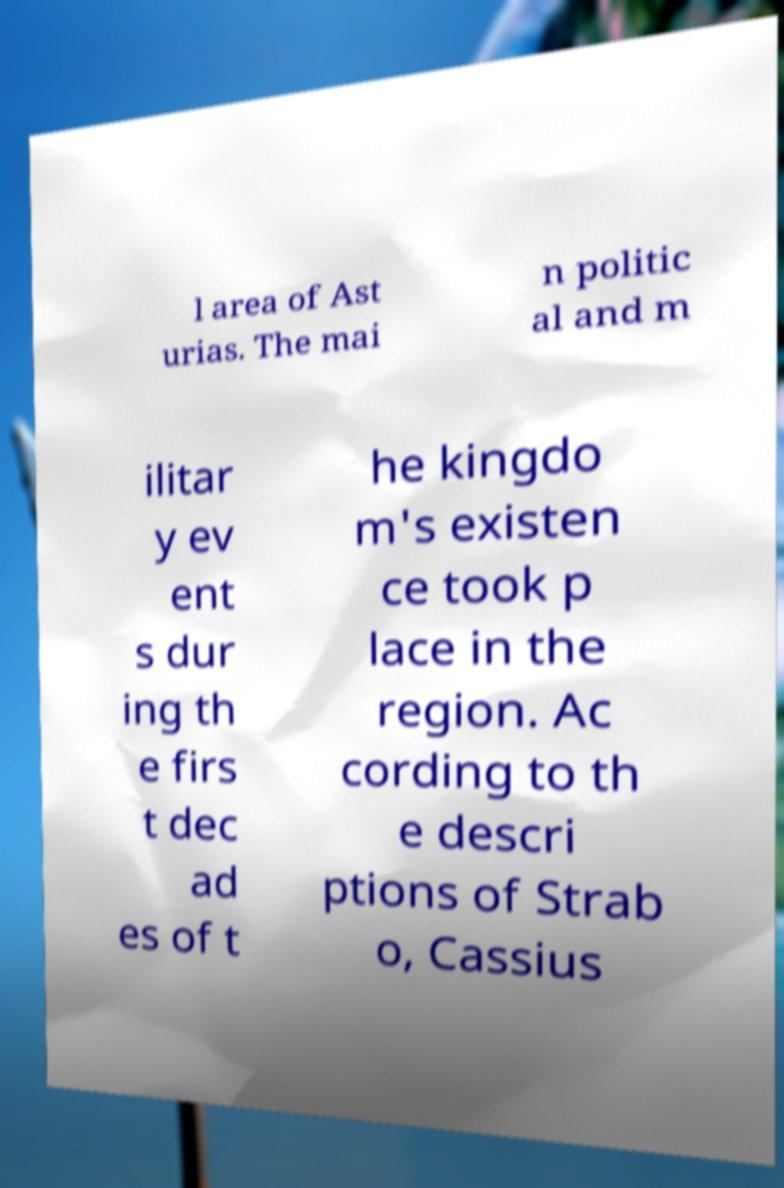Please identify and transcribe the text found in this image. l area of Ast urias. The mai n politic al and m ilitar y ev ent s dur ing th e firs t dec ad es of t he kingdo m's existen ce took p lace in the region. Ac cording to th e descri ptions of Strab o, Cassius 